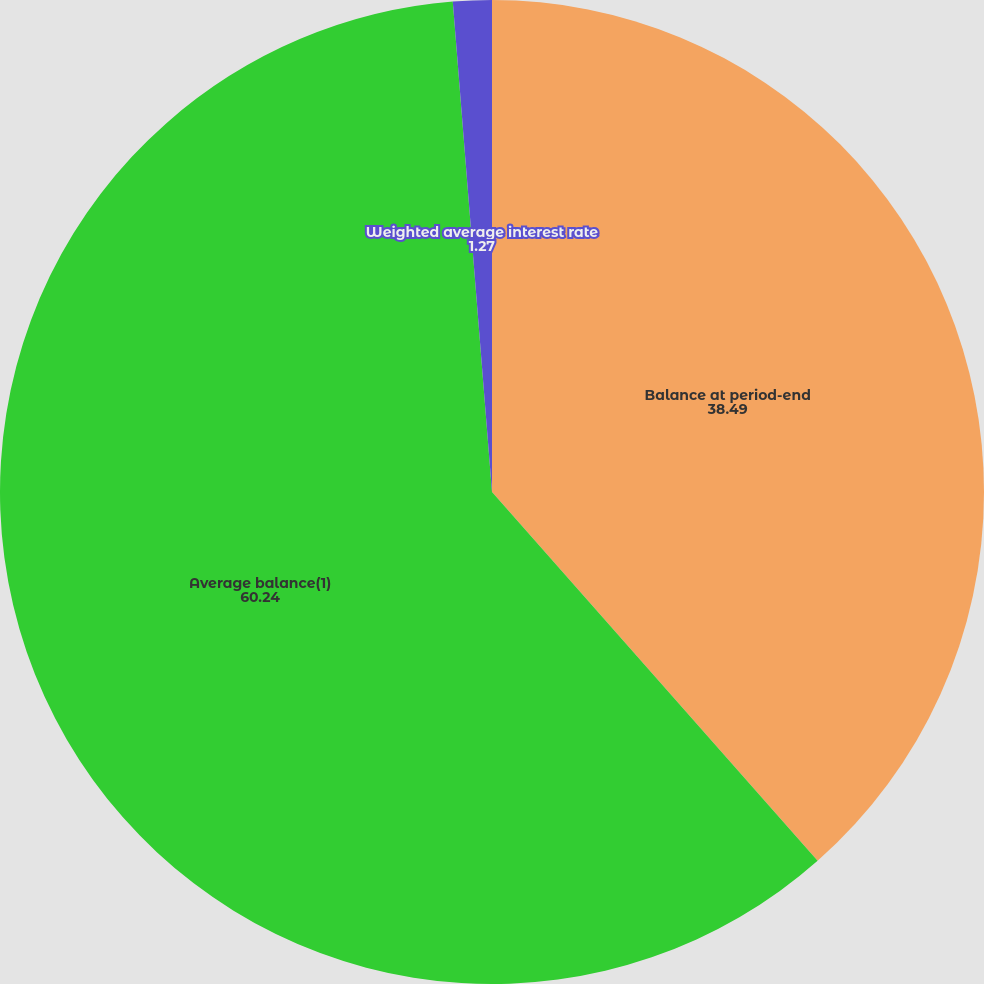Convert chart. <chart><loc_0><loc_0><loc_500><loc_500><pie_chart><fcel>Balance at period-end<fcel>Average balance(1)<fcel>Weighted average interest rate<nl><fcel>38.49%<fcel>60.24%<fcel>1.27%<nl></chart> 